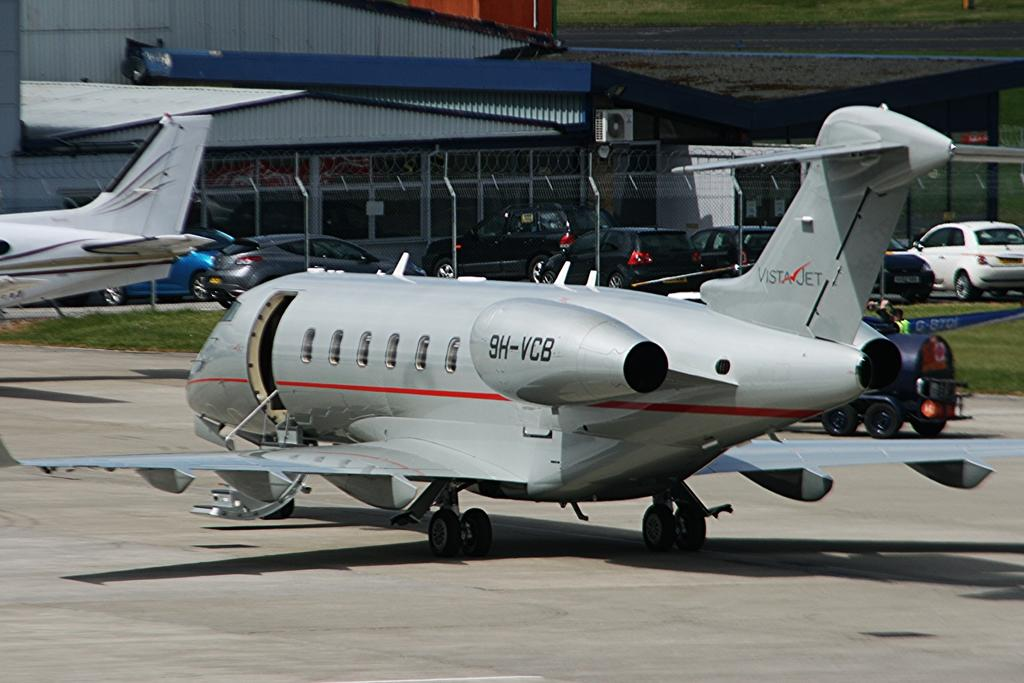<image>
Relay a brief, clear account of the picture shown. The identification number of the Vista Jet is 9H-VCB 